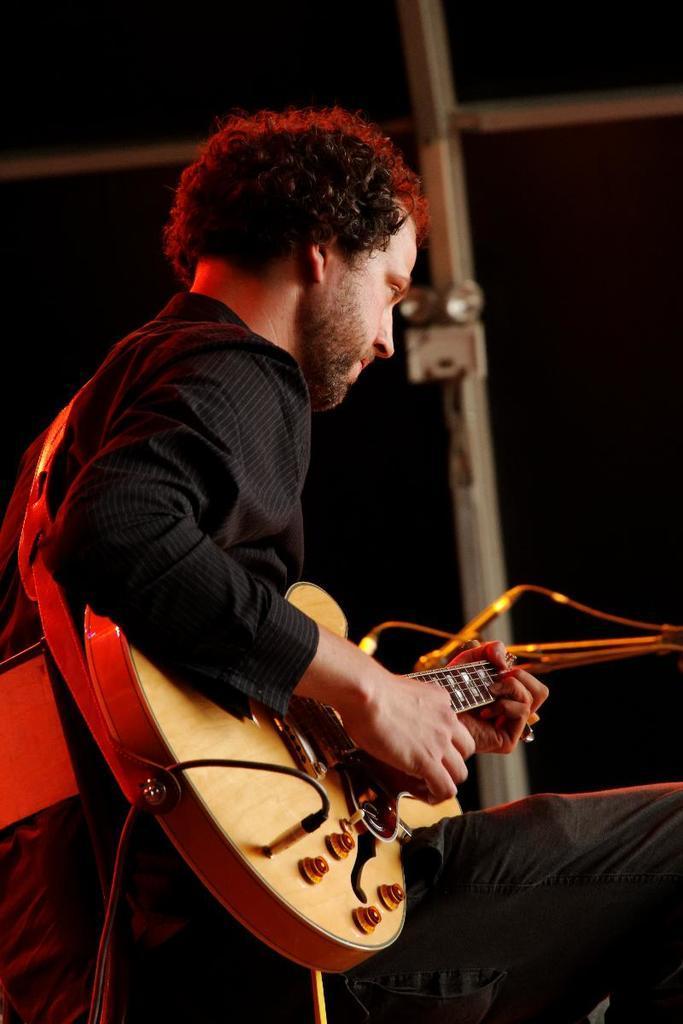How would you summarize this image in a sentence or two? There is a man sitting and playing guitar. He is wearing a black dress and has long hair. Cables are attached to the guitar. In the background there is wall and lights. 